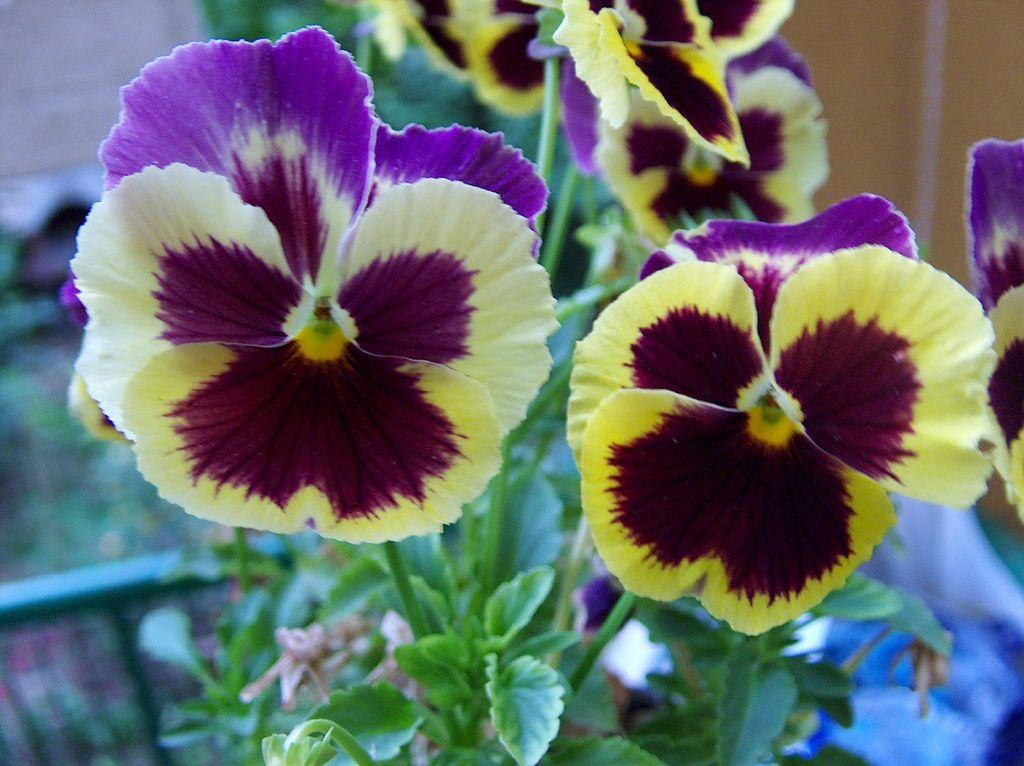What is present in the image? There is a plant in the image. What can be observed about the plant? The plant has flowers. What colors are the flowers? The flowers are in yellow and purple colors. Is there a pickle next to the plant in the image? No, there is no pickle present in the image. Can the flowers be seen performing magic in the image? No, the flowers are not performing magic in the image; they are simply flowers on a plant. 